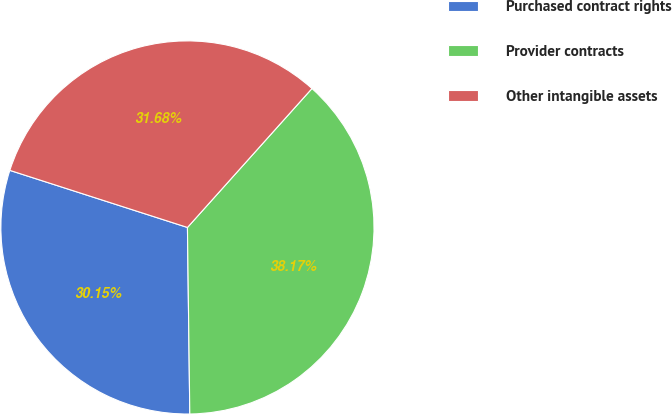Convert chart. <chart><loc_0><loc_0><loc_500><loc_500><pie_chart><fcel>Purchased contract rights<fcel>Provider contracts<fcel>Other intangible assets<nl><fcel>30.15%<fcel>38.17%<fcel>31.68%<nl></chart> 